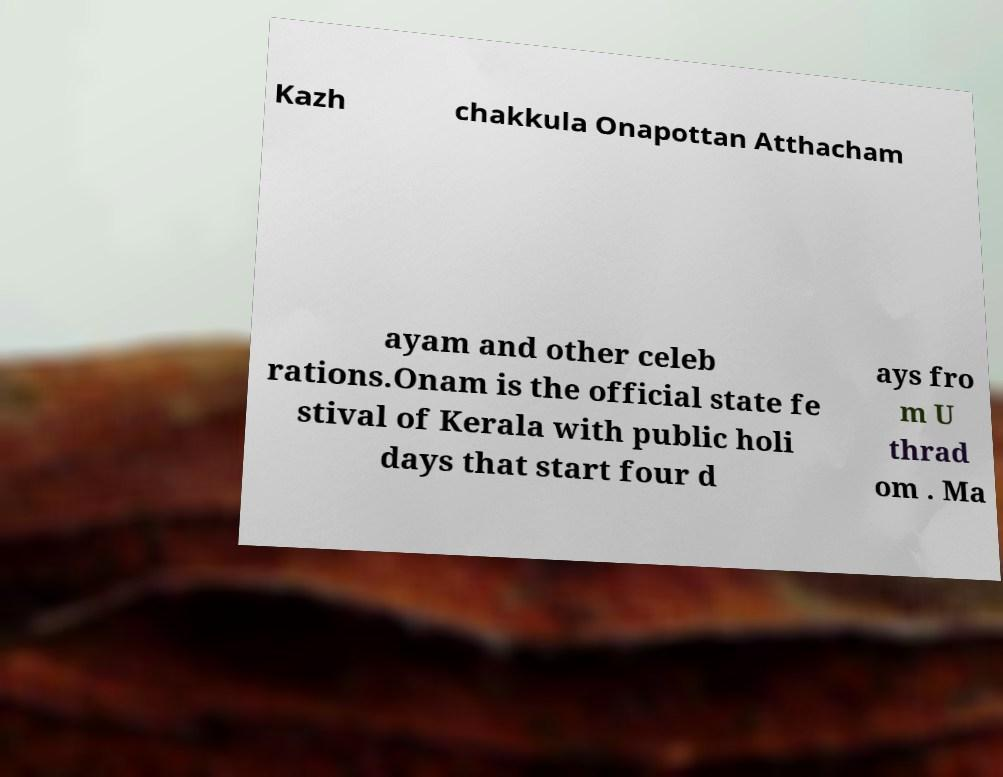Can you accurately transcribe the text from the provided image for me? Kazh chakkula Onapottan Atthacham ayam and other celeb rations.Onam is the official state fe stival of Kerala with public holi days that start four d ays fro m U thrad om . Ma 